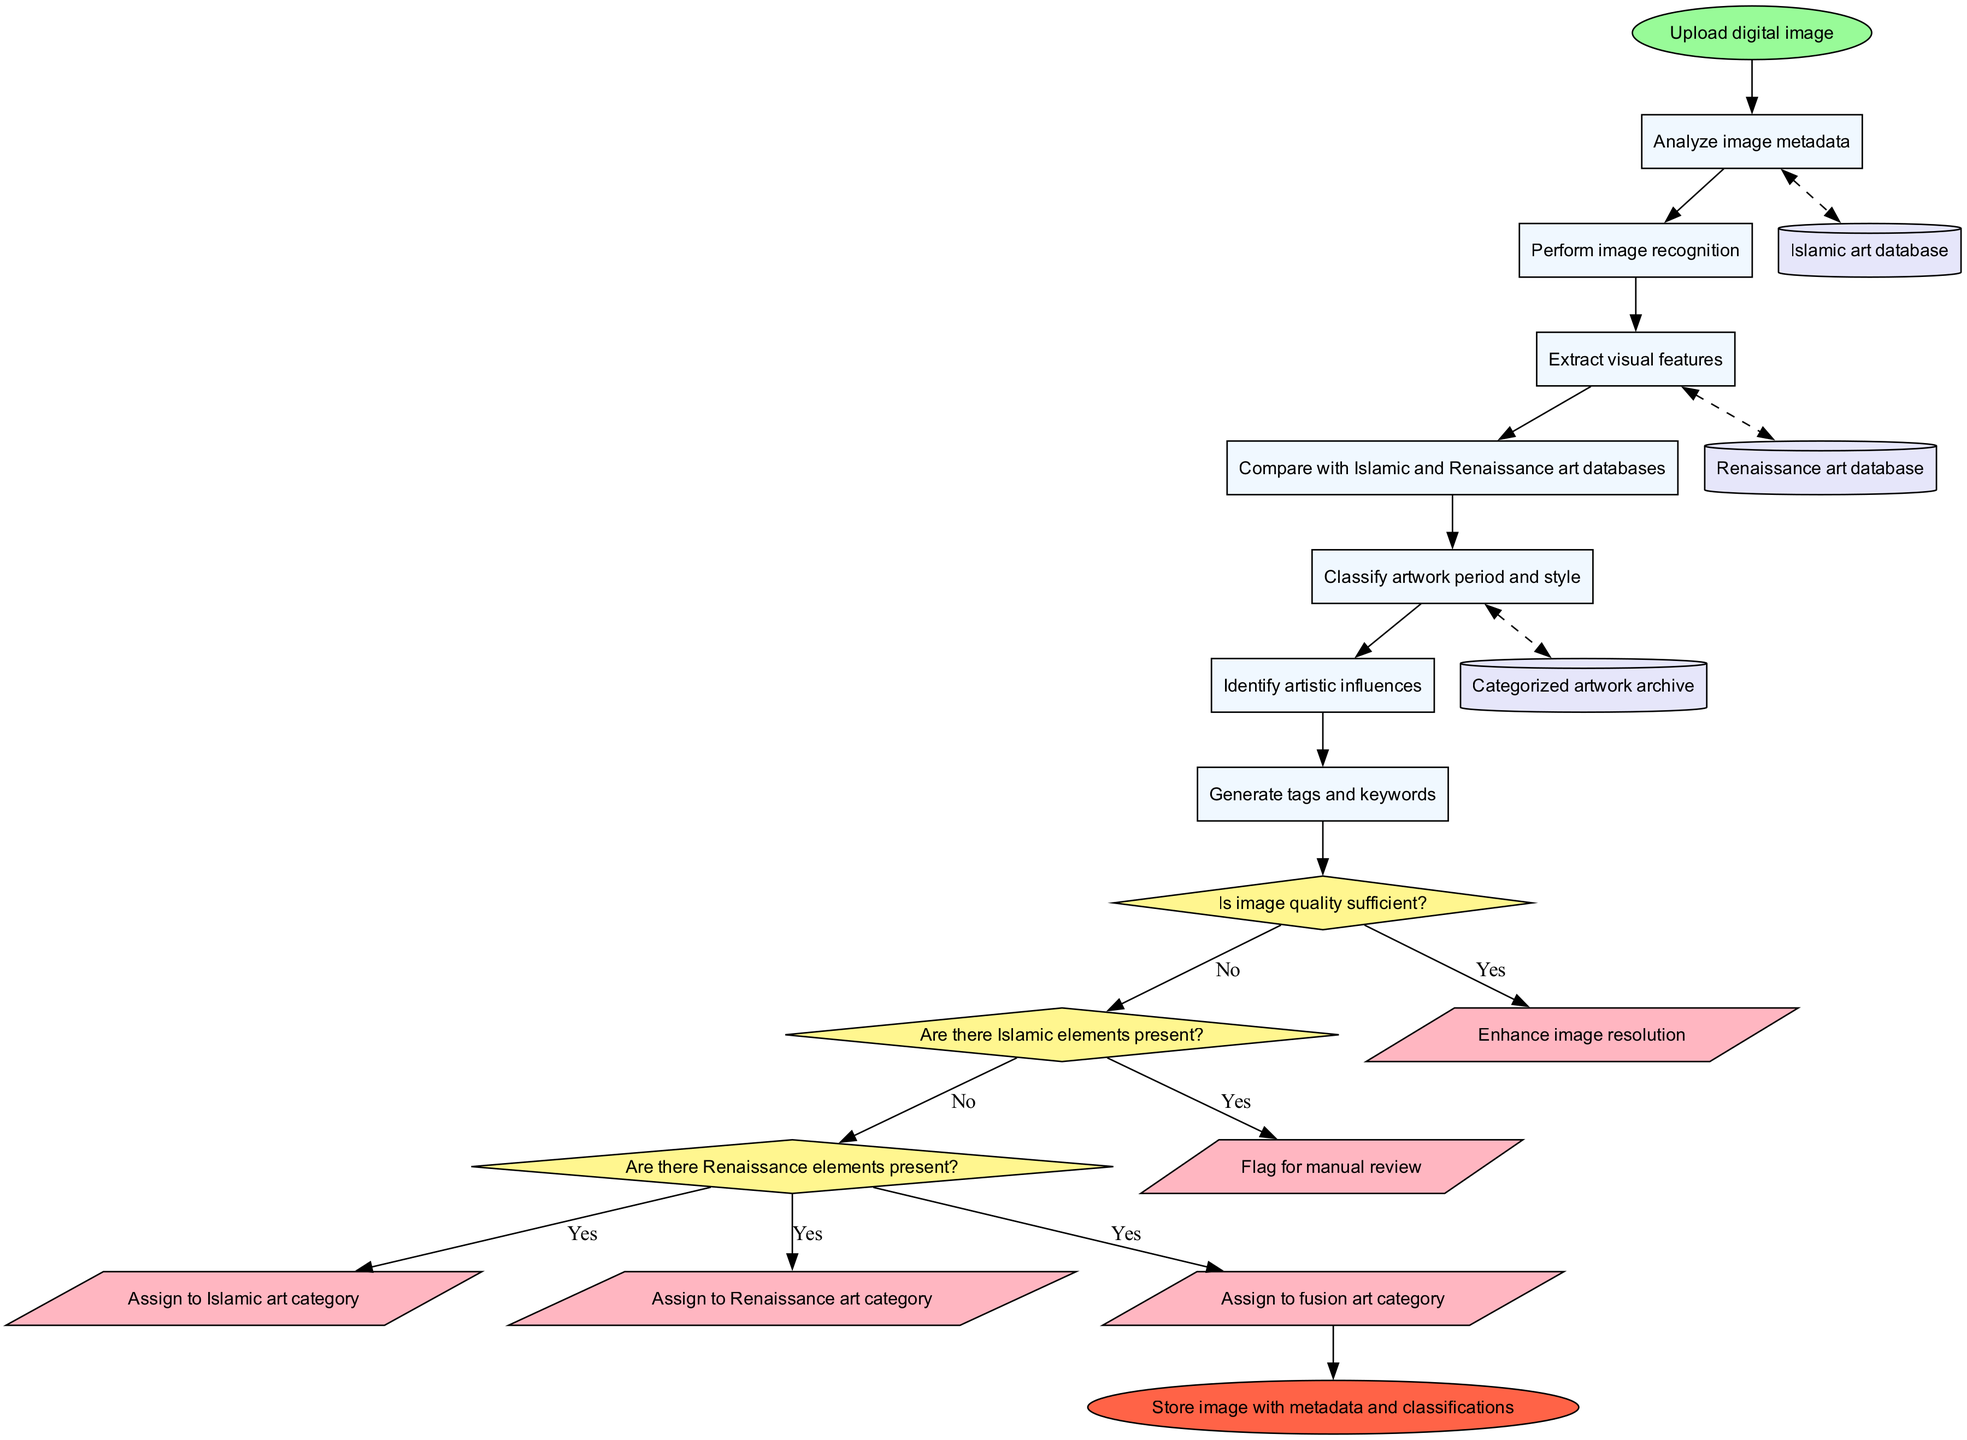What is the first process in the flowchart? The first process listed in the diagram is "Analyze image metadata," which follows the starting node.
Answer: Analyze image metadata How many decisions are present in the diagram? There are three decisions identified in the flowchart.
Answer: 3 What happens if the image quality is insufficient? If the image quality is insufficient, the flowchart directs to the action "Enhance image resolution."
Answer: Enhance image resolution Which action corresponds to the presence of Renaissance elements? The action "Assign to Renaissance art category" follows the decision about the presence of Renaissance elements.
Answer: Assign to Renaissance art category How many data stores are there in total? The flowchart indicates there are three data stores that are used for storing categorized artwork and its associated databases.
Answer: 3 What is the final action before reaching the end node? The last action performed in the flowchart before reaching the end node is "Generate tags and keywords."
Answer: Generate tags and keywords What action is taken if Islamic elements are present? If Islamic elements are present, the artwork is classified with the action "Assign to Islamic art category."
Answer: Assign to Islamic art category In total, how many actions are represented in the diagram? The diagram represents five different actions related to the classification and archiving procedures.
Answer: 5 What does the flowchart do with the image after classifying it? After classifying the image, the flowchart indicates it "Stores image with metadata and classifications."
Answer: Stores image with metadata and classifications 